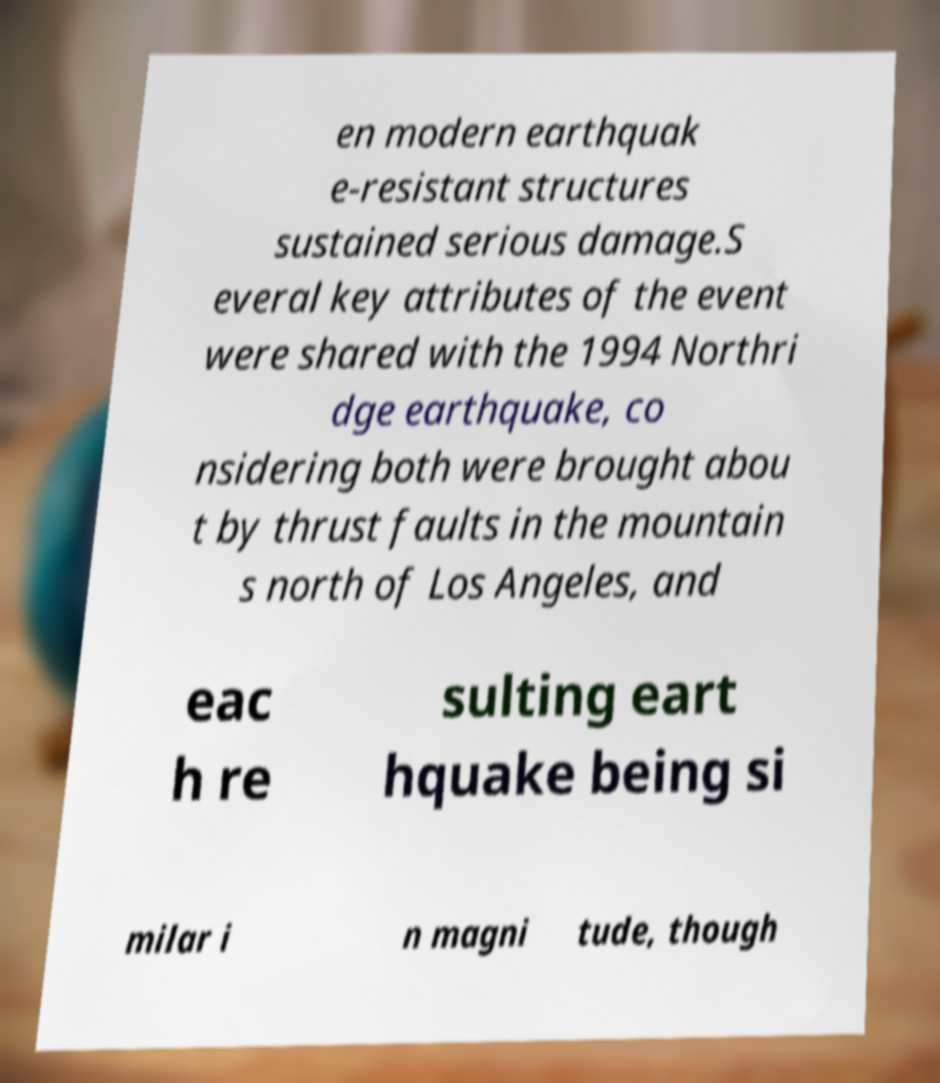Can you read and provide the text displayed in the image?This photo seems to have some interesting text. Can you extract and type it out for me? en modern earthquak e-resistant structures sustained serious damage.S everal key attributes of the event were shared with the 1994 Northri dge earthquake, co nsidering both were brought abou t by thrust faults in the mountain s north of Los Angeles, and eac h re sulting eart hquake being si milar i n magni tude, though 